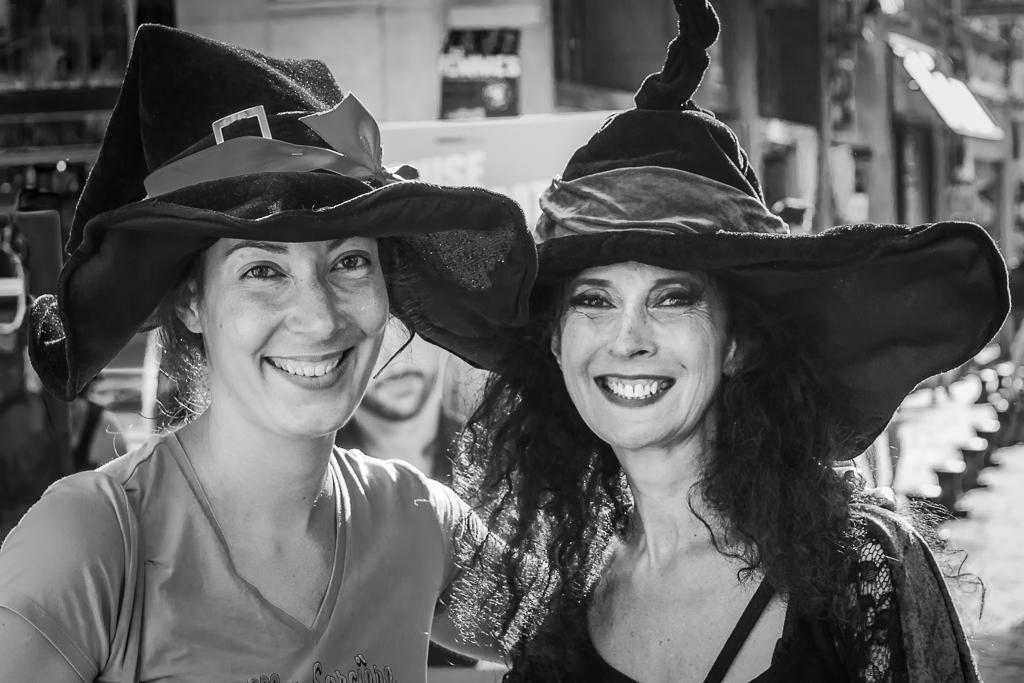What is the color scheme of the image? The image is black and white. How many people are in the image? There are two women in the image. What is the facial expression of the women? The women are smiling. Can you describe the background of the image? The background is blurred in the image. What else can be seen in the image besides the women? There is a hoarding and a building visible in the image. What type of square can be seen on the coast in the image? There is no square or coast present in the image; it is a black and white image featuring two women, a blurred background, a hoarding, and a building. 